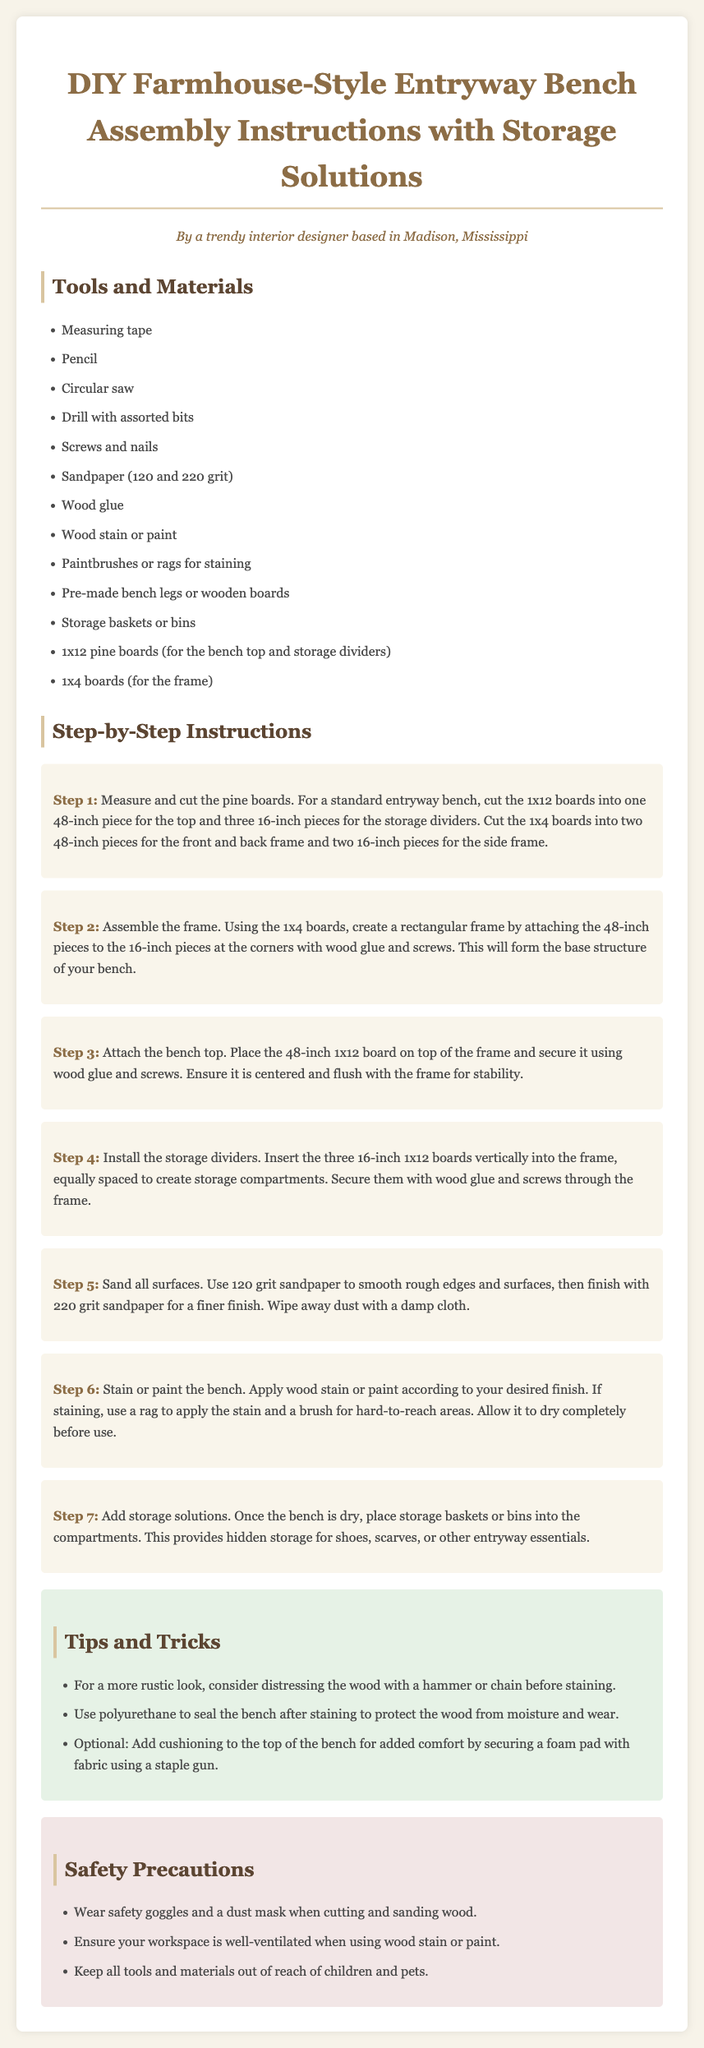What is the length of the bench top? The document specifies that the 1x12 boards for the top should be cut into one 48-inch piece for the top.
Answer: 48-inch How many storage compartments are created? The instructions indicate that there are three 16-inch pieces used as storage dividers, which creates three compartments.
Answer: Three What grit sandpaper is used first? The instructions mention using 120 grit sandpaper to smooth rough edges and surfaces first.
Answer: 120 grit What type of wood is used for the storage dividers? The instructions state that the storage dividers are made of 1x12 pine boards.
Answer: 1x12 pine boards What safety gear should be worn while cutting wood? The document advises wearing safety goggles when cutting wood.
Answer: Safety goggles How should the stain be applied? According to the instructions, the stain should be applied with a rag for easy areas and a brush for hard-to-reach areas.
Answer: With a rag and brush What material is recommended for cushioning the bench? The tips suggest using a foam pad secured with fabric as cushioning for the top of the bench.
Answer: Foam pad What are the colors used in the document's title? The color information for the title specifies that it uses #8c6d46.
Answer: #8c6d46 What is an optional addition to enhance bench comfort? The document mentions that adding cushioning with a foam pad is optional for comfort.
Answer: Cushioning with foam pad 